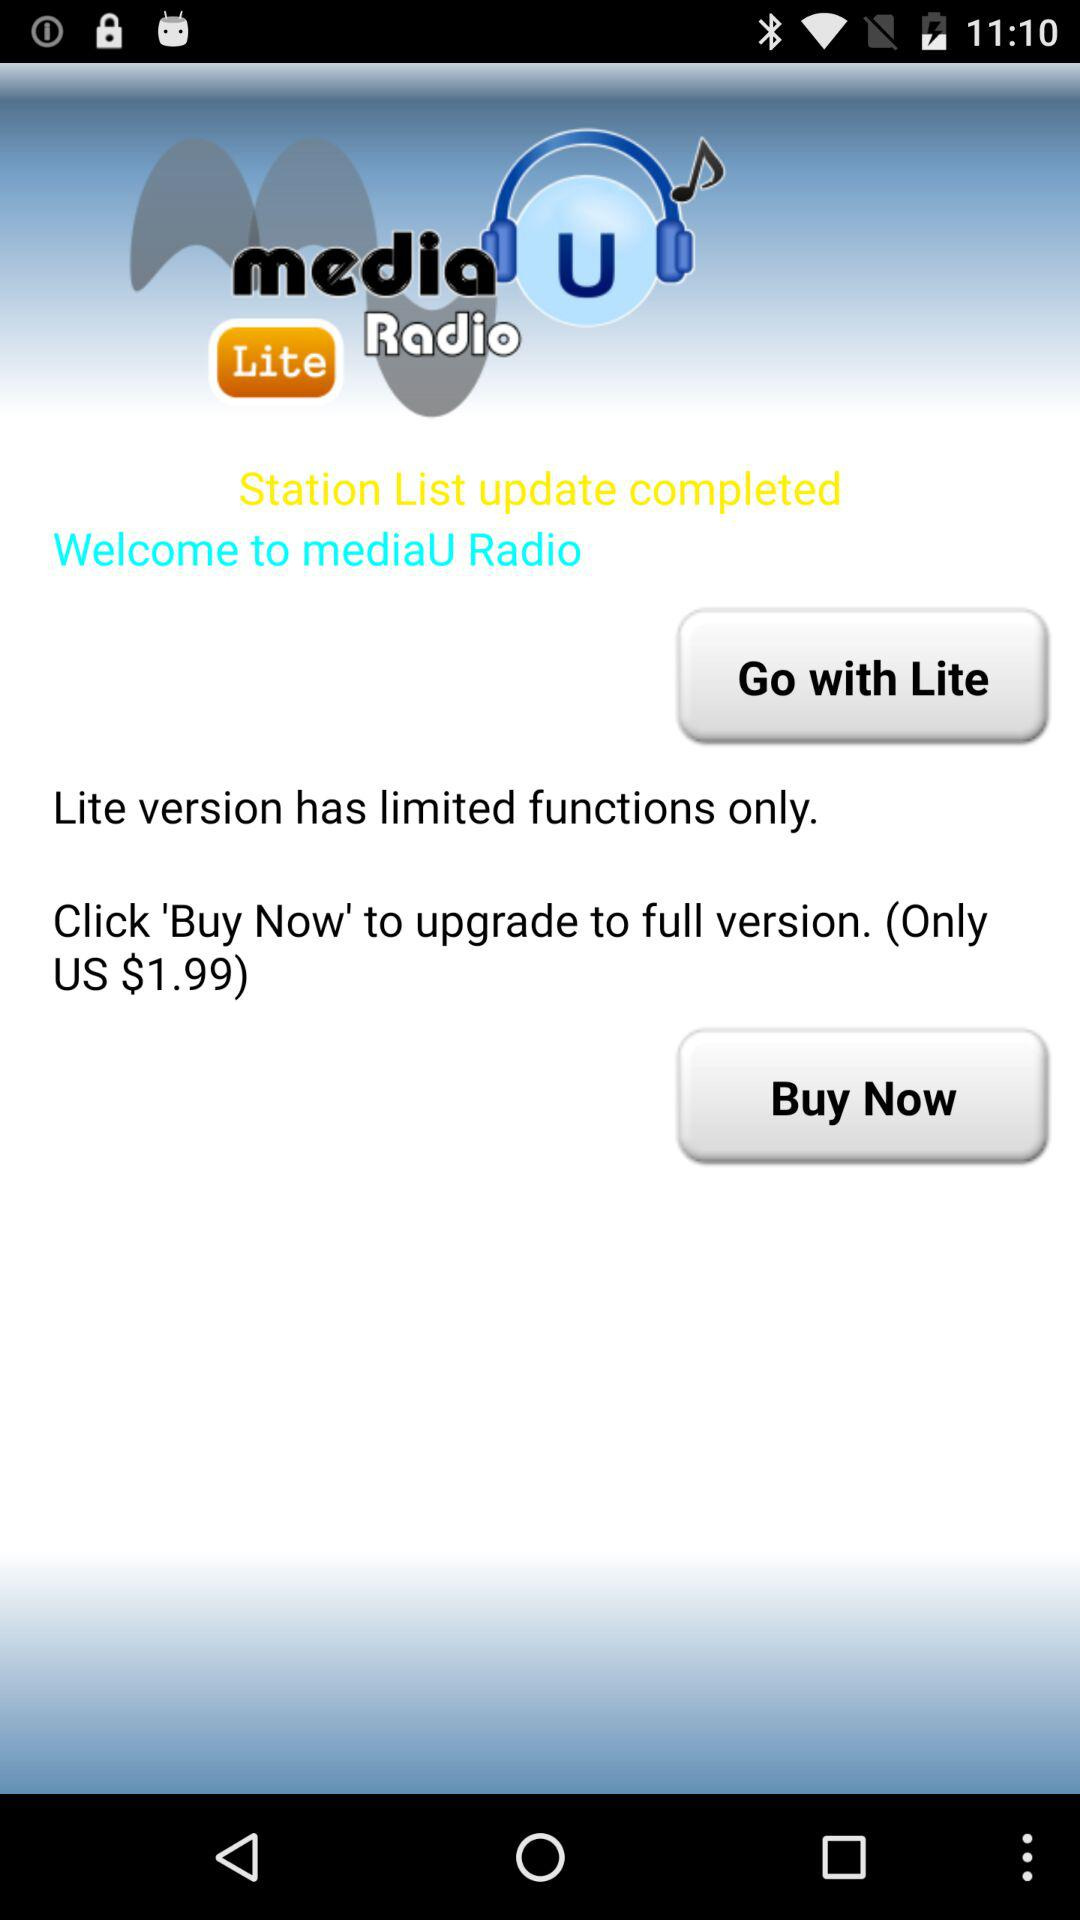What is the price of the upgraded version? The price of the upgraded version is US$1.99. 